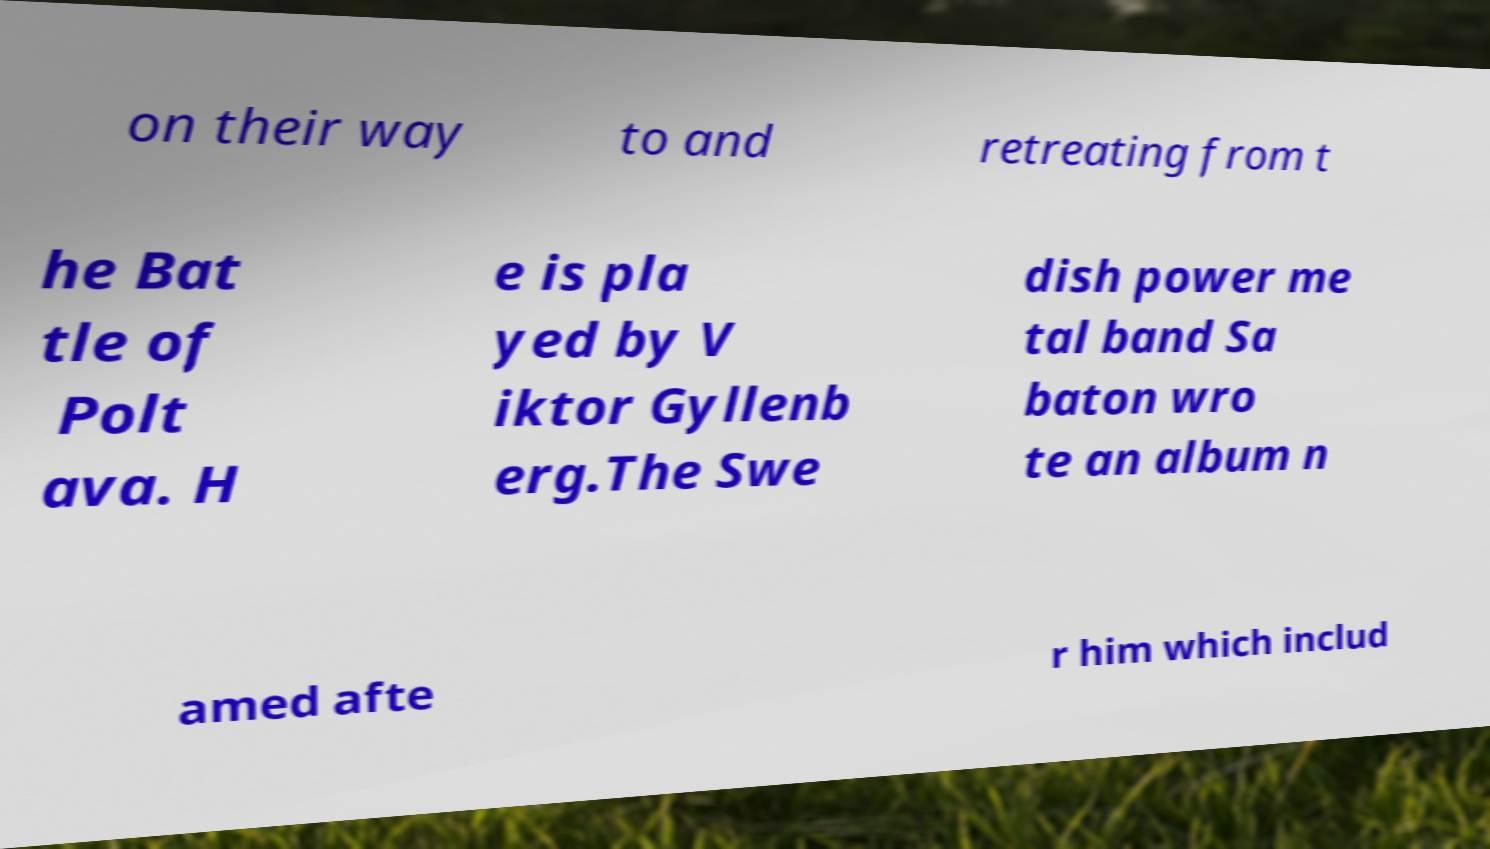Please identify and transcribe the text found in this image. on their way to and retreating from t he Bat tle of Polt ava. H e is pla yed by V iktor Gyllenb erg.The Swe dish power me tal band Sa baton wro te an album n amed afte r him which includ 